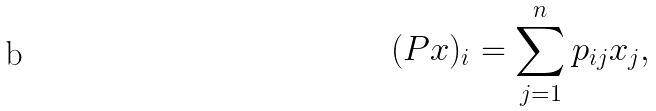Convert formula to latex. <formula><loc_0><loc_0><loc_500><loc_500>( P x ) _ { i } = \sum _ { j = 1 } ^ { n } p _ { i j } x _ { j } ,</formula> 